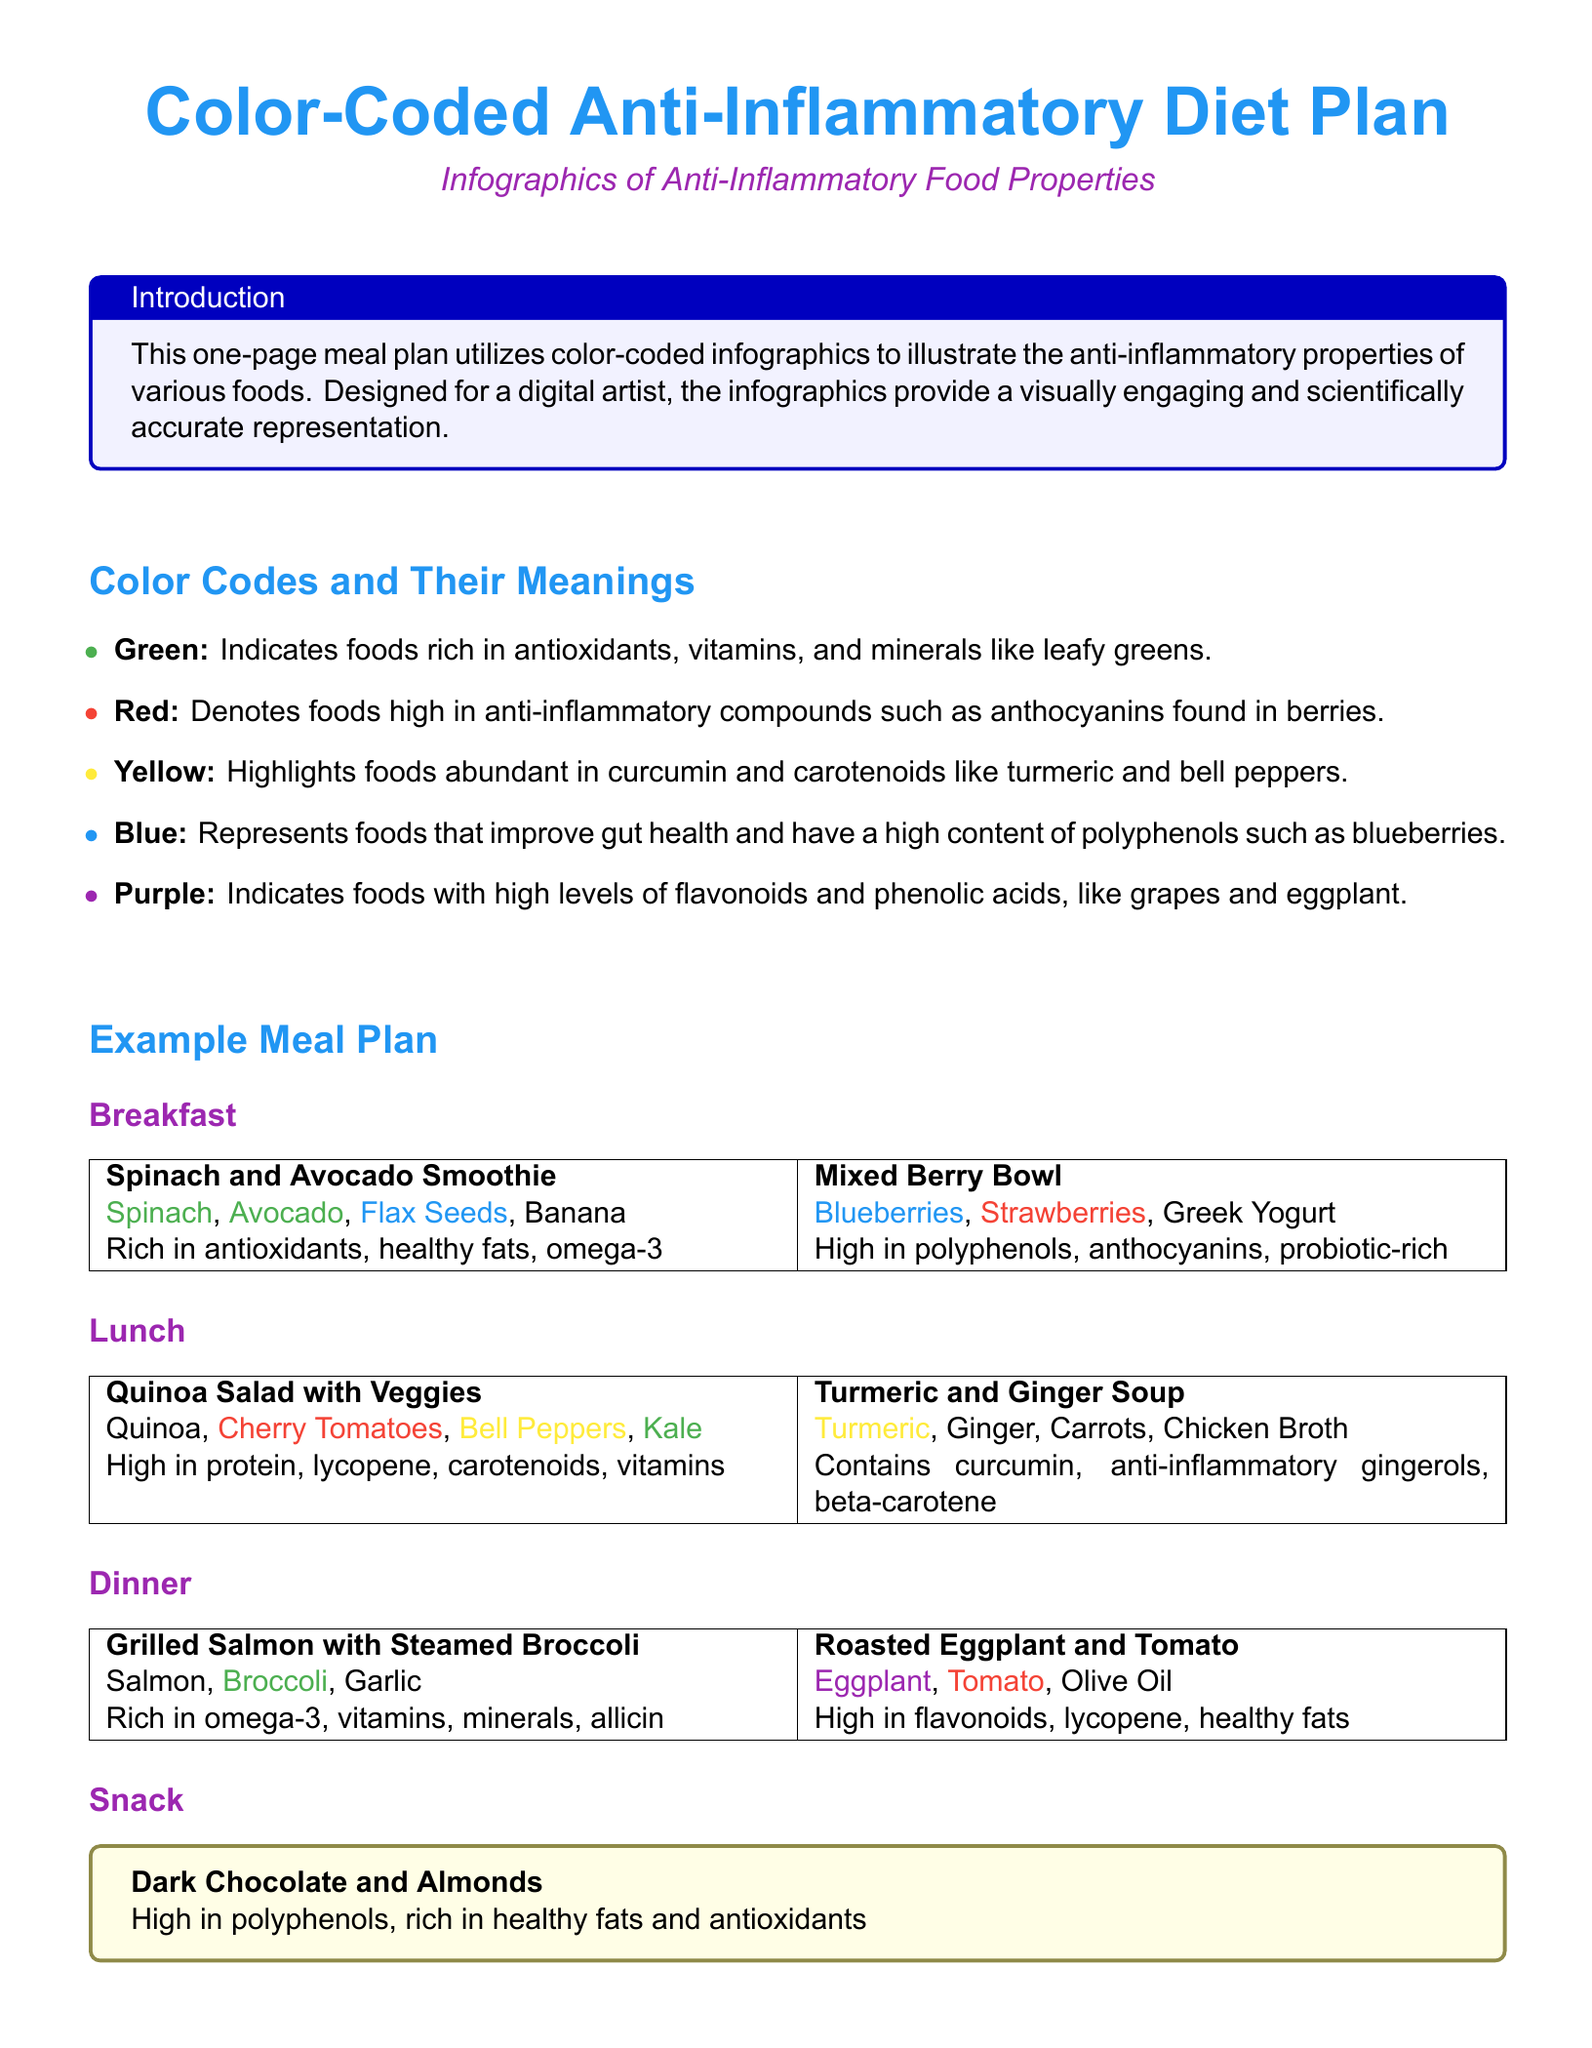What color indicates foods rich in antioxidants? The document states that green indicates foods rich in antioxidants, vitamins, and minerals like leafy greens.
Answer: Green What is the main protein source in the dinner meal? The document lists grilled salmon as the main protein source for dinner.
Answer: Salmon Which food in the breakfast is high in omega-3? The document mentions flax seeds as being rich in omega-3 in the breakfast meal.
Answer: Flax Seeds What color highlights foods abundant in curcumin? The document specifies that yellow highlights foods abundant in curcumin and carotenoids, such as turmeric and bell peppers.
Answer: Yellow What snack is mentioned in the meal plan? The meal plan includes dark chocolate and almonds as a snack.
Answer: Dark Chocolate and Almonds Which food contributes to gut health according to the meal plan? The document states that blueberries are linked to improved gut health.
Answer: Blueberries How many sections does the meal plan contain? The document includes four meal sections: breakfast, lunch, dinner, and snack.
Answer: Four What does the purple color represent in the meal plan? The purple color indicates foods with high levels of flavonoids and phenolic acids, like grapes and eggplant.
Answer: Foods with high levels of flavonoids and phenolic acids Which nutrient is highlighted for reducing joint pain? The document highlights curcumin as the compound that helps reduce joint pain.
Answer: Curcumin 